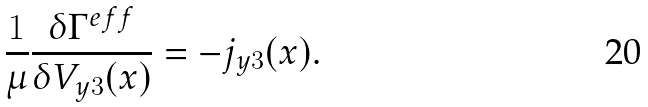Convert formula to latex. <formula><loc_0><loc_0><loc_500><loc_500>\frac { 1 } { \mu } \frac { \delta \Gamma ^ { e f f } } { \delta V _ { y 3 } ( x ) } = - j _ { y 3 } ( x ) .</formula> 